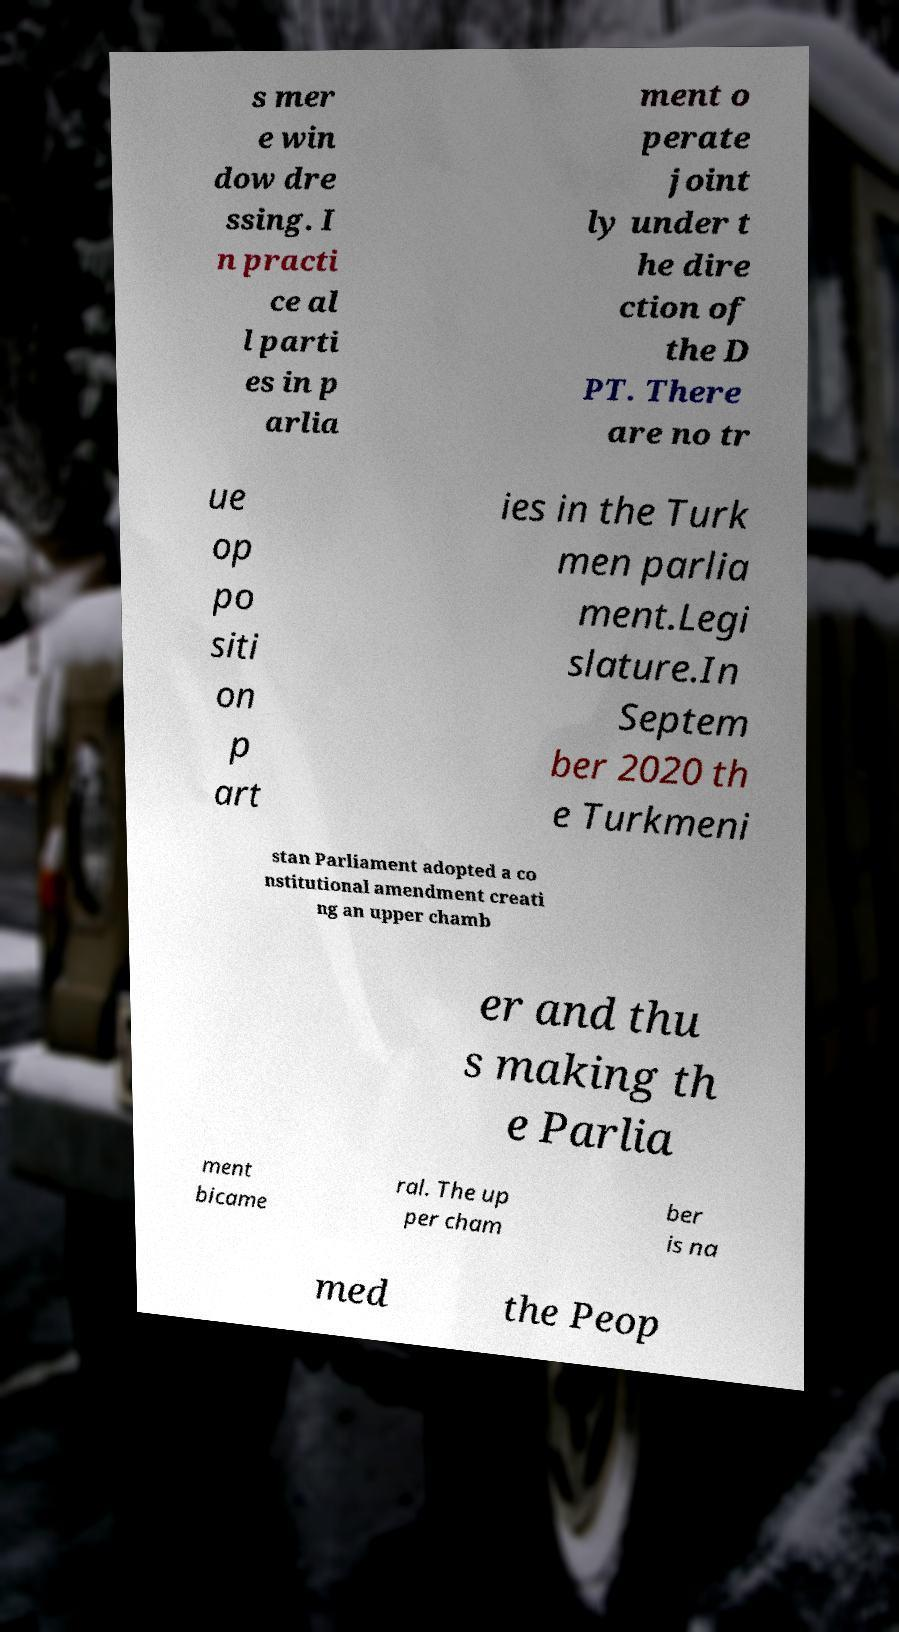Could you extract and type out the text from this image? s mer e win dow dre ssing. I n practi ce al l parti es in p arlia ment o perate joint ly under t he dire ction of the D PT. There are no tr ue op po siti on p art ies in the Turk men parlia ment.Legi slature.In Septem ber 2020 th e Turkmeni stan Parliament adopted a co nstitutional amendment creati ng an upper chamb er and thu s making th e Parlia ment bicame ral. The up per cham ber is na med the Peop 